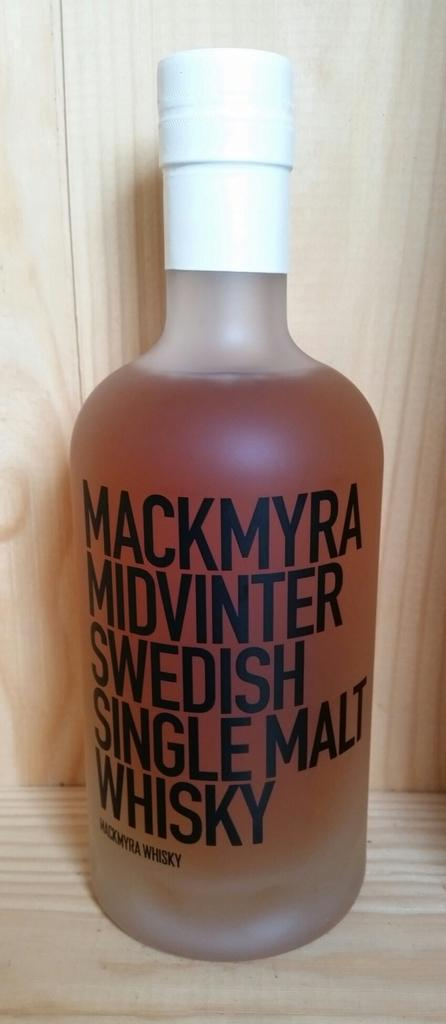<image>
Offer a succinct explanation of the picture presented. A medium sized frosted glass bottle contains single malt whisky. 